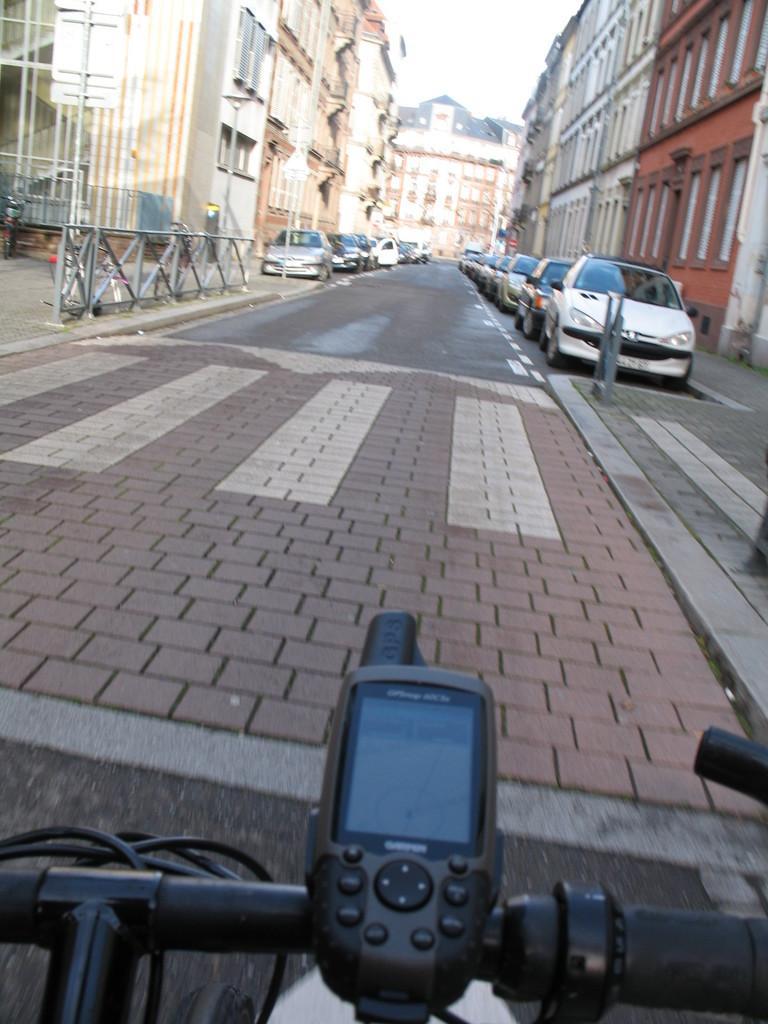Could you give a brief overview of what you see in this image? In the foreground of this image, on the bottom, it seems like a bicycle. In the background, there is a road, few vehicles, side path, buildings and the sky. 